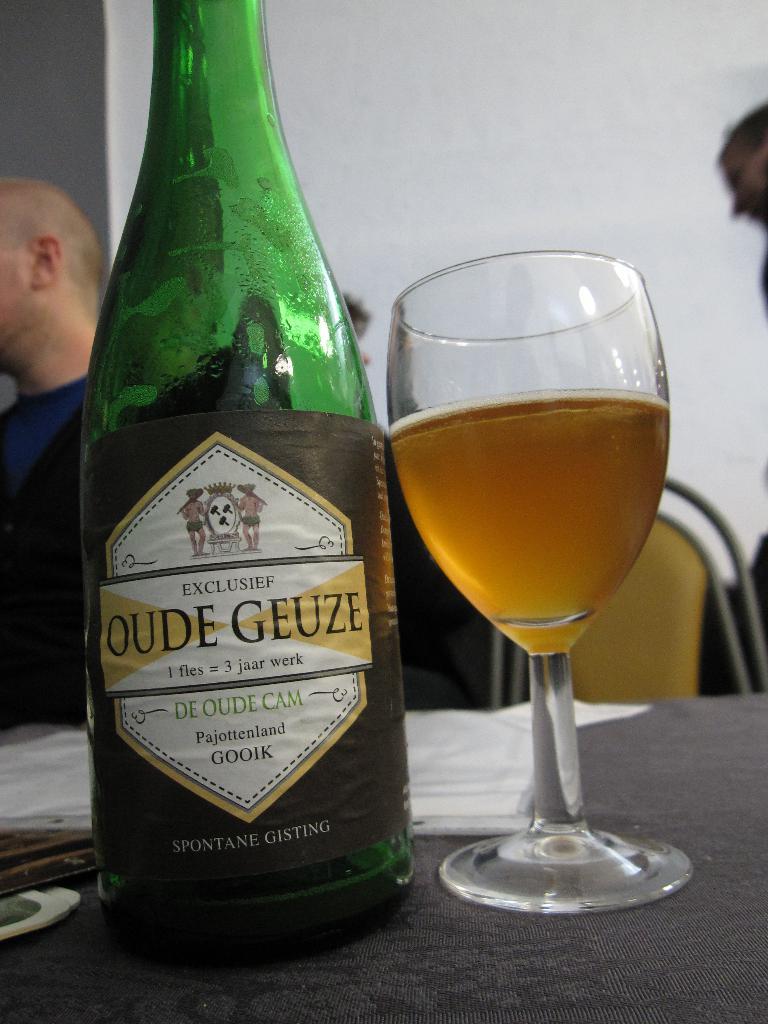What is the name of this alcohol?
Your answer should be very brief. Oude geuze. How many "jaar werk" equals "1 fles?"?
Your answer should be very brief. 3. 